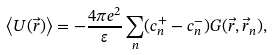Convert formula to latex. <formula><loc_0><loc_0><loc_500><loc_500>\left < U ( \vec { r } ) \right > = - \frac { 4 \pi e ^ { 2 } } { \varepsilon } \sum _ { n } ( c ^ { + } _ { n } - c ^ { - } _ { n } ) G ( \vec { r } , \vec { r } _ { n } ) ,</formula> 